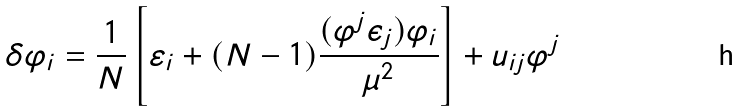Convert formula to latex. <formula><loc_0><loc_0><loc_500><loc_500>\delta \varphi _ { i } = \frac { 1 } { N } \left [ \varepsilon _ { i } + ( N - 1 ) \frac { ( \varphi ^ { j } \epsilon _ { j } ) \varphi _ { i } } { \mu ^ { 2 } } \right ] + u _ { i j } \varphi ^ { j }</formula> 